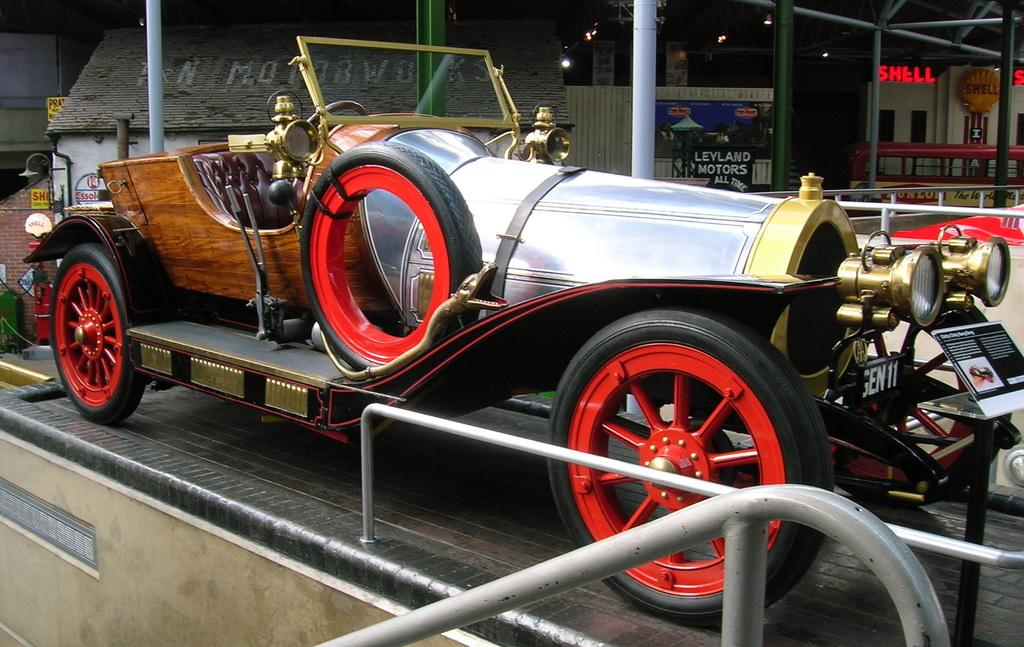What is the main subject in the foreground of the image? There is a vehicle in the foreground of the image. What can be seen at the bottom of the image? There is railing at the bottom of the image. What is present in the image besides the vehicle and railing? There is a pole, poles in the background, lights, text, and walls visible in the background of the image. What type of kite is being flown by the person in the image? There is no person or kite present in the image. What is the person's chin doing in the image? There is no person or chin present in the image. 